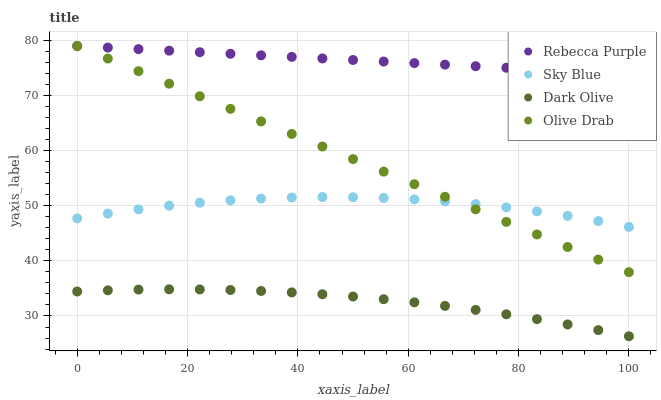Does Dark Olive have the minimum area under the curve?
Answer yes or no. Yes. Does Rebecca Purple have the maximum area under the curve?
Answer yes or no. Yes. Does Rebecca Purple have the minimum area under the curve?
Answer yes or no. No. Does Dark Olive have the maximum area under the curve?
Answer yes or no. No. Is Rebecca Purple the smoothest?
Answer yes or no. Yes. Is Sky Blue the roughest?
Answer yes or no. Yes. Is Dark Olive the smoothest?
Answer yes or no. No. Is Dark Olive the roughest?
Answer yes or no. No. Does Dark Olive have the lowest value?
Answer yes or no. Yes. Does Rebecca Purple have the lowest value?
Answer yes or no. No. Does Olive Drab have the highest value?
Answer yes or no. Yes. Does Dark Olive have the highest value?
Answer yes or no. No. Is Sky Blue less than Rebecca Purple?
Answer yes or no. Yes. Is Rebecca Purple greater than Sky Blue?
Answer yes or no. Yes. Does Rebecca Purple intersect Olive Drab?
Answer yes or no. Yes. Is Rebecca Purple less than Olive Drab?
Answer yes or no. No. Is Rebecca Purple greater than Olive Drab?
Answer yes or no. No. Does Sky Blue intersect Rebecca Purple?
Answer yes or no. No. 